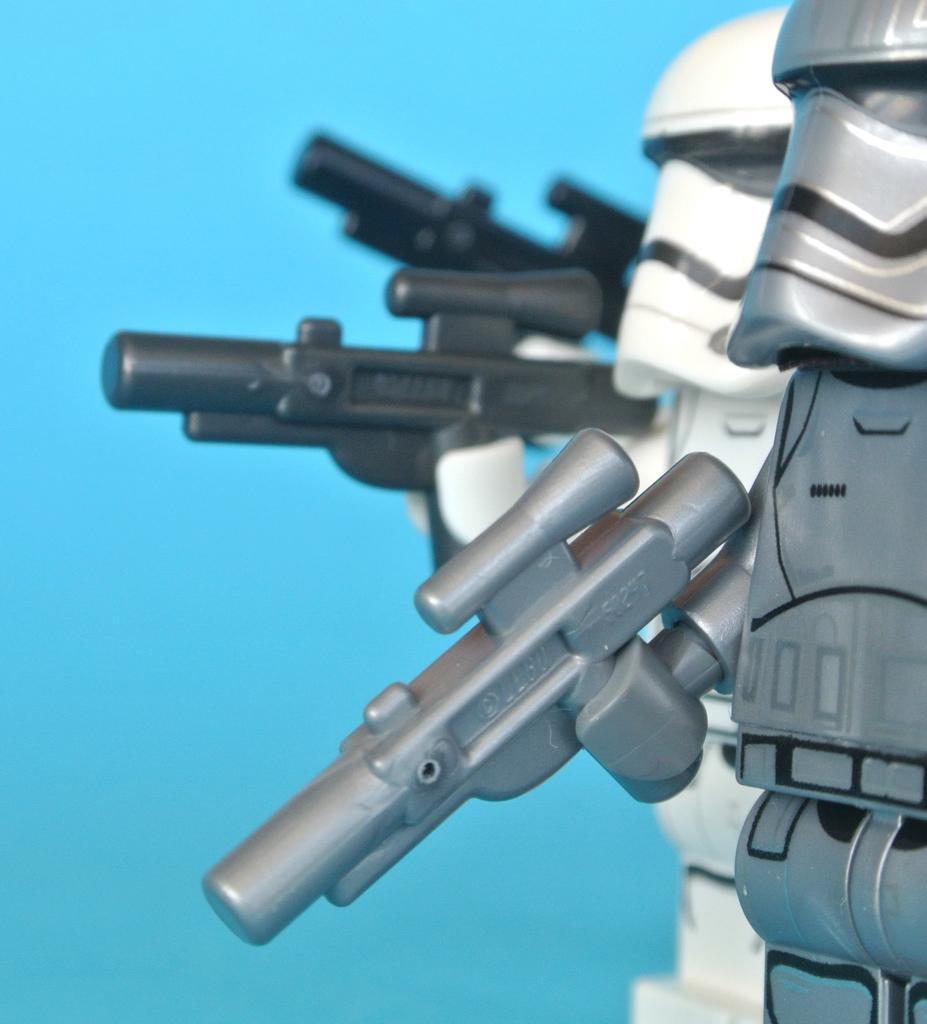Please provide a concise description of this image. In this image I can see few toys and the toys are holding few weapons. The toys are in black, white and silver color, and I can see blue color background. 